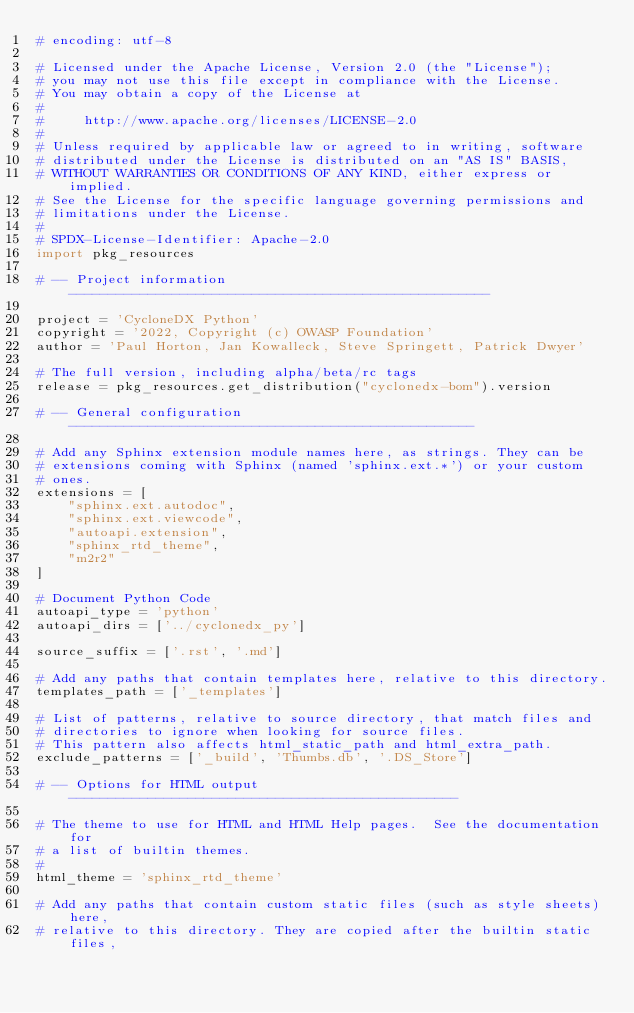<code> <loc_0><loc_0><loc_500><loc_500><_Python_># encoding: utf-8

# Licensed under the Apache License, Version 2.0 (the "License");
# you may not use this file except in compliance with the License.
# You may obtain a copy of the License at
#
#     http://www.apache.org/licenses/LICENSE-2.0
#
# Unless required by applicable law or agreed to in writing, software
# distributed under the License is distributed on an "AS IS" BASIS,
# WITHOUT WARRANTIES OR CONDITIONS OF ANY KIND, either express or implied.
# See the License for the specific language governing permissions and
# limitations under the License.
#
# SPDX-License-Identifier: Apache-2.0
import pkg_resources

# -- Project information -----------------------------------------------------

project = 'CycloneDX Python'
copyright = '2022, Copyright (c) OWASP Foundation'
author = 'Paul Horton, Jan Kowalleck, Steve Springett, Patrick Dwyer'

# The full version, including alpha/beta/rc tags
release = pkg_resources.get_distribution("cyclonedx-bom").version

# -- General configuration ---------------------------------------------------

# Add any Sphinx extension module names here, as strings. They can be
# extensions coming with Sphinx (named 'sphinx.ext.*') or your custom
# ones.
extensions = [
    "sphinx.ext.autodoc",
    "sphinx.ext.viewcode",
    "autoapi.extension",
    "sphinx_rtd_theme",
    "m2r2"
]

# Document Python Code
autoapi_type = 'python'
autoapi_dirs = ['../cyclonedx_py']

source_suffix = ['.rst', '.md']

# Add any paths that contain templates here, relative to this directory.
templates_path = ['_templates']

# List of patterns, relative to source directory, that match files and
# directories to ignore when looking for source files.
# This pattern also affects html_static_path and html_extra_path.
exclude_patterns = ['_build', 'Thumbs.db', '.DS_Store']

# -- Options for HTML output -------------------------------------------------

# The theme to use for HTML and HTML Help pages.  See the documentation for
# a list of builtin themes.
#
html_theme = 'sphinx_rtd_theme'

# Add any paths that contain custom static files (such as style sheets) here,
# relative to this directory. They are copied after the builtin static files,</code> 